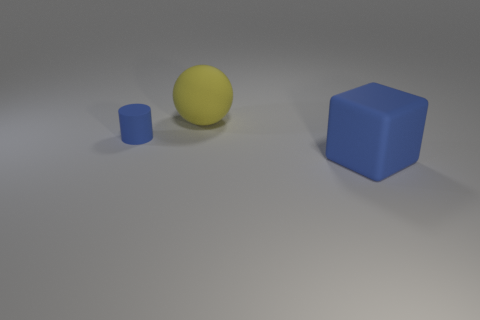Is there any other thing that is the same size as the blue rubber cylinder?
Keep it short and to the point. No. There is another rubber object that is the same color as the tiny object; what is its shape?
Offer a very short reply. Cube. Do the yellow rubber sphere and the blue rubber cube have the same size?
Your answer should be very brief. Yes. How many objects are either objects that are in front of the big yellow object or big matte things that are left of the blue cube?
Your response must be concise. 3. There is a blue object that is behind the thing that is to the right of the yellow thing; what is its material?
Your response must be concise. Rubber. What number of other things are made of the same material as the big yellow thing?
Provide a succinct answer. 2. Is the large yellow thing the same shape as the large blue matte thing?
Your answer should be very brief. No. There is a rubber object that is on the left side of the yellow sphere; how big is it?
Give a very brief answer. Small. Do the sphere and the blue rubber thing behind the large rubber block have the same size?
Ensure brevity in your answer.  No. Are there fewer small blue things that are to the right of the tiny cylinder than large green shiny cubes?
Keep it short and to the point. No. 